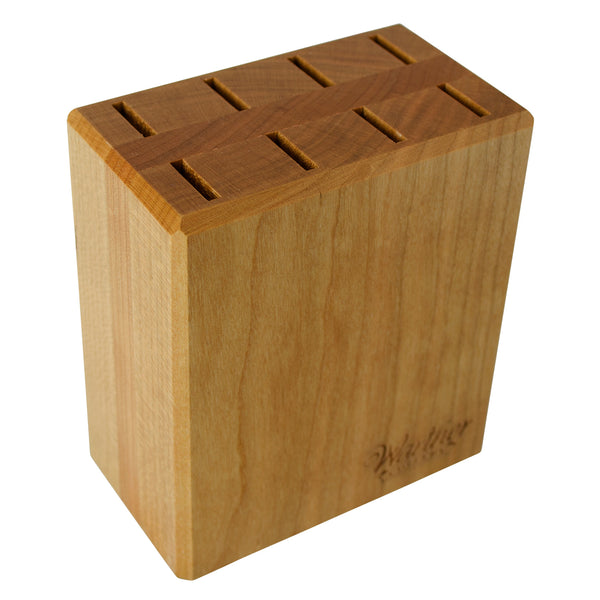Given the structure and design of the knife holder, what could be inferred about the types and sizes of knives it is intended to hold? Based on the structure and design, the knife holder is intended to hold a variety of knives, likely a set that includes different sizes and purposes. The varying widths of the slots suggest that it can accommodate both narrow paring knives and wider chef's knives. The depth of the slots, which cannot be precisely determined from the image, should be sufficient to hold standard kitchen knives securely. The uniform spacing and the number of slots indicate it's meant for a comprehensive set, possibly including a bread knife, carving knife, and utility knives, among others. 